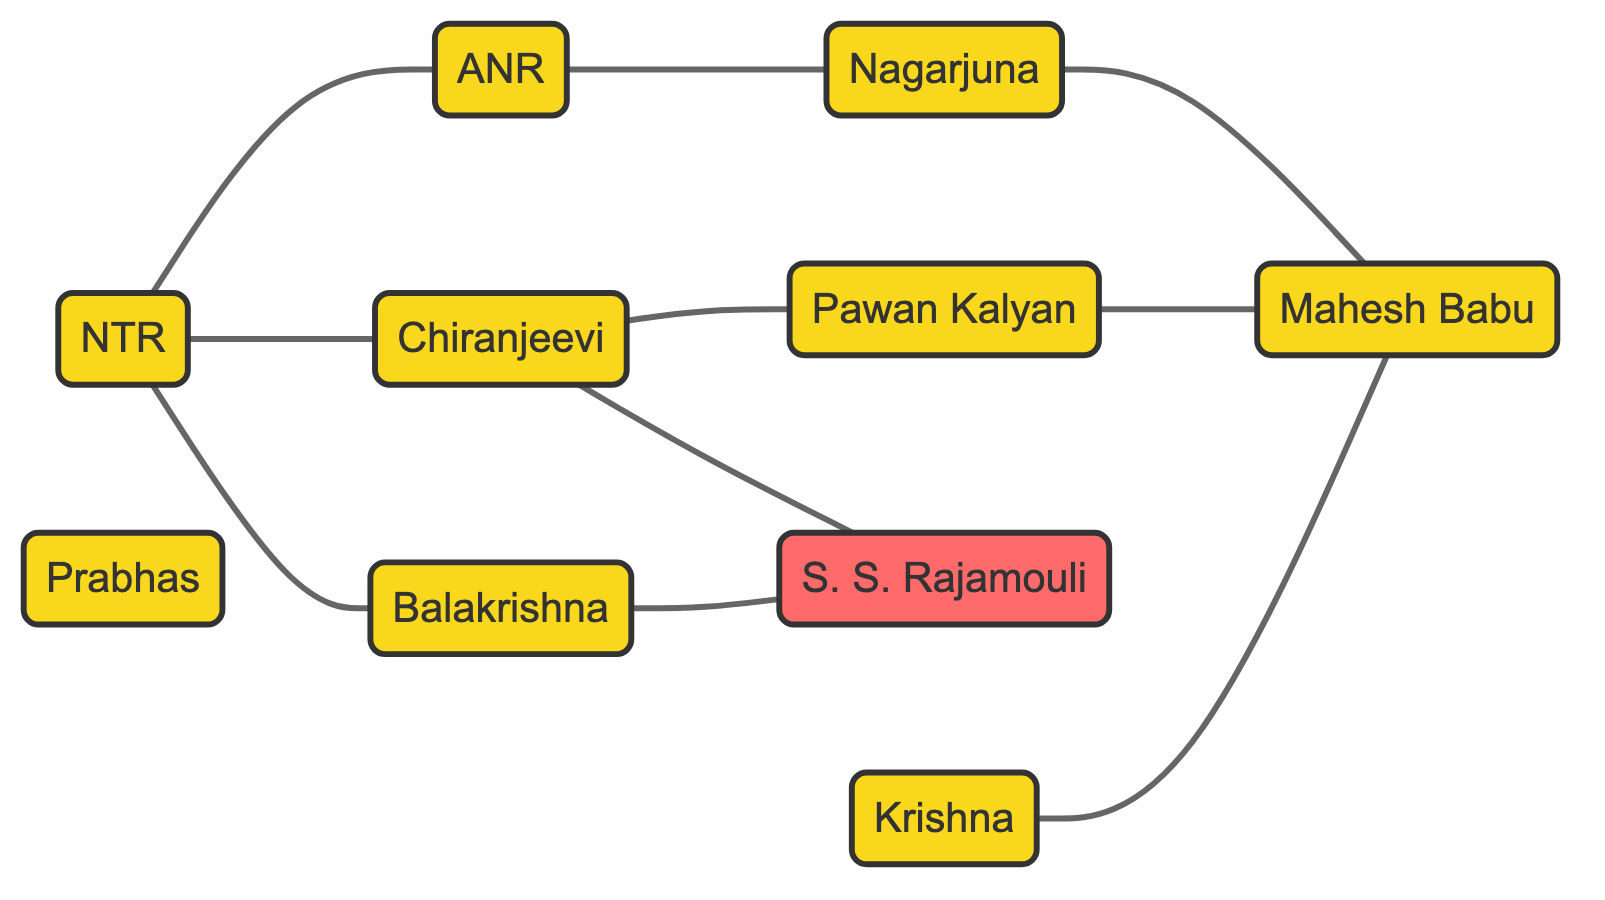What is the total number of actors listed in the diagram? Count the number of unique nodes labeled as actors in the diagram. The given nodes are NTR, ANR, Chiranjeevi, Balakrishna, Nagarjuna, Pawan Kalyan, Mahesh Babu, Prabhas, and Krishna, yielding a total of 9 actors.
Answer: 9 Who is the son of NTR in the diagram? Look for the relationship labeled "Father-Son" that includes NTR. According to the edges listed, Balakrishna has a "Father-Son" relationship with NTR, indicating Balakrishna is his son.
Answer: Balakrishna Which two actors are indicated as contemporaries? Identify the edge that has the relationship labeled "Contemporaries." The edge between Pawan Kalyan and Mahesh Babu specifies that they are contemporaries.
Answer: Pawan Kalyan and Mahesh Babu How many collaborations are depicted in the diagram? Review the edges for relationships labeled as "Collaborators." The edges involving Chiranjeevi and Rajamouli, Nagarjuna and Mahesh Babu, and Balakrishna and Rajamouli demonstrate that there are 3 collaborations.
Answer: 3 Which actor has influenced Chiranjeevi according to the diagram? Check the edges connected to Chiranjeevi to find any that denote "Influence." The edge between NTR and Chiranjeevi shows that NTR has had an influence on Chiranjeevi.
Answer: NTR What is the relationship between Nagarjuna and Mahesh Babu? Examine the edges for their connection. The edge specifies that Nagarjuna and Mahesh Babu are "Collaborators," providing insight into their professional relationship.
Answer: Collaborators Which actor is both a father and has a son according to the diagram? Identify any actor that has both a "Father-Son" relationship and is also a parent to another actor. NTR (father to Balakrishna) and Krishna (father to Mahesh Babu) both fulfill this condition. As the question pertains to a singular actor, we could select either one based on context.
Answer: NTR Who are the brothers listed in the diagram? Look for the edge labeled "Brothers." The edge connecting Chiranjeevi and Pawan Kalyan specifies that they are brothers.
Answer: Chiranjeevi and Pawan Kalyan How many edges connect NTR to other actors in the diagram? Count the number of edges where NTR is mentioned as either source or target. The edges are: NTR-ANR, NTR-Chiranjeevi, and NTR-Balakrishna, totaling 3 edges.
Answer: 3 